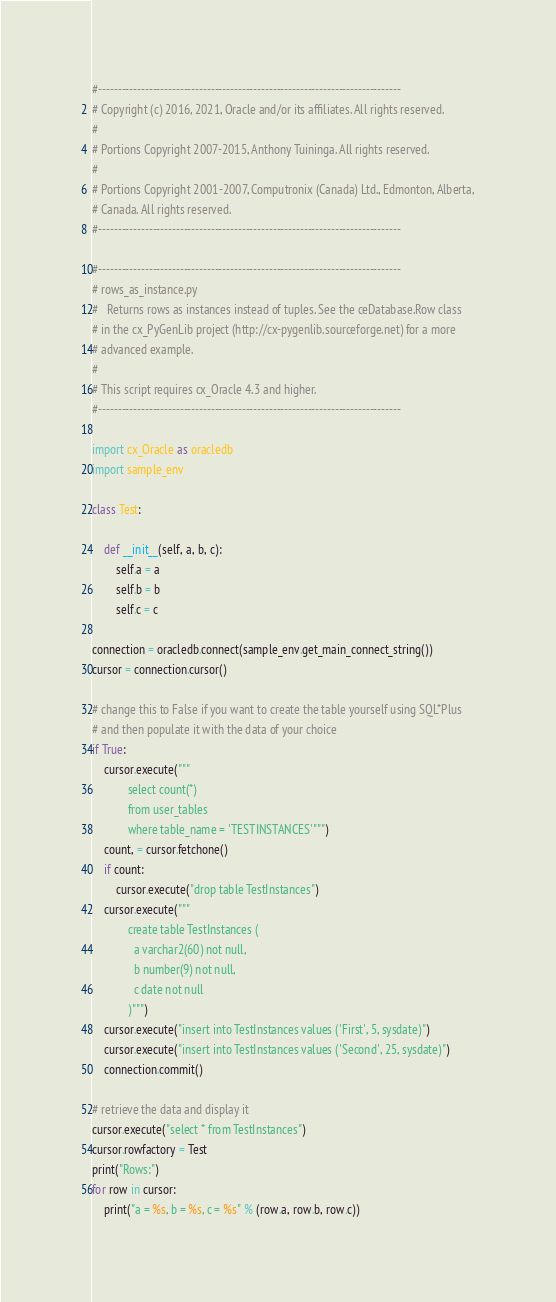<code> <loc_0><loc_0><loc_500><loc_500><_Python_>#------------------------------------------------------------------------------
# Copyright (c) 2016, 2021, Oracle and/or its affiliates. All rights reserved.
#
# Portions Copyright 2007-2015, Anthony Tuininga. All rights reserved.
#
# Portions Copyright 2001-2007, Computronix (Canada) Ltd., Edmonton, Alberta,
# Canada. All rights reserved.
#------------------------------------------------------------------------------

#------------------------------------------------------------------------------
# rows_as_instance.py
#   Returns rows as instances instead of tuples. See the ceDatabase.Row class
# in the cx_PyGenLib project (http://cx-pygenlib.sourceforge.net) for a more
# advanced example.
#
# This script requires cx_Oracle 4.3 and higher.
#------------------------------------------------------------------------------

import cx_Oracle as oracledb
import sample_env

class Test:

    def __init__(self, a, b, c):
        self.a = a
        self.b = b
        self.c = c

connection = oracledb.connect(sample_env.get_main_connect_string())
cursor = connection.cursor()

# change this to False if you want to create the table yourself using SQL*Plus
# and then populate it with the data of your choice
if True:
    cursor.execute("""
            select count(*)
            from user_tables
            where table_name = 'TESTINSTANCES'""")
    count, = cursor.fetchone()
    if count:
        cursor.execute("drop table TestInstances")
    cursor.execute("""
            create table TestInstances (
              a varchar2(60) not null,
              b number(9) not null,
              c date not null
            )""")
    cursor.execute("insert into TestInstances values ('First', 5, sysdate)")
    cursor.execute("insert into TestInstances values ('Second', 25, sysdate)")
    connection.commit()

# retrieve the data and display it
cursor.execute("select * from TestInstances")
cursor.rowfactory = Test
print("Rows:")
for row in cursor:
    print("a = %s, b = %s, c = %s" % (row.a, row.b, row.c))
</code> 